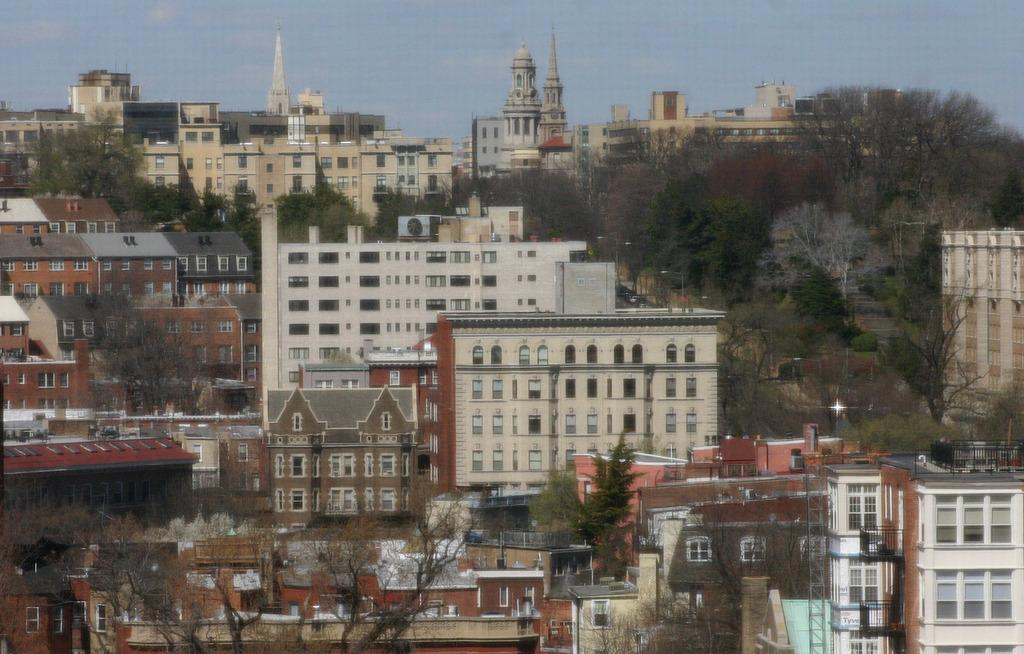What type of structures can be seen in the image? There are buildings in the image. What natural elements are present in the image? There are trees in the image. What man-made objects can be seen in the image? There are poles in the image. What else can be seen in the image besides buildings, trees, and poles? There are other objects in the image. What is visible in the background of the image? The sky is visible in the background of the image. What type of arithmetic problem is being solved on the pole in the image? There is no arithmetic problem present in the image; it features buildings, trees, poles, and other objects. Can you see any smoke coming from the buildings in the image? There is no smoke visible in the image; only buildings, trees, poles, and other objects are present. 